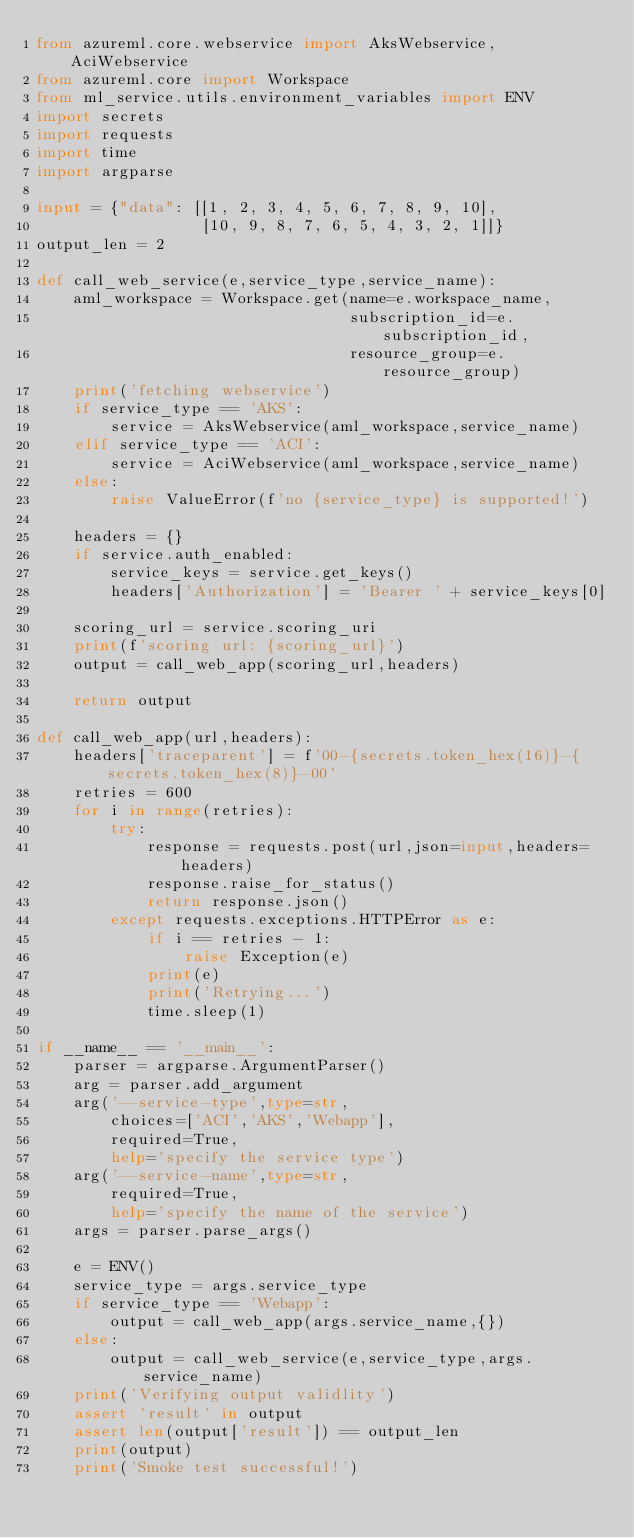<code> <loc_0><loc_0><loc_500><loc_500><_Python_>from azureml.core.webservice import AksWebservice,AciWebservice
from azureml.core import Workspace
from ml_service.utils.environment_variables import ENV
import secrets
import requests
import time
import argparse

input = {"data": [[1, 2, 3, 4, 5, 6, 7, 8, 9, 10],
                  [10, 9, 8, 7, 6, 5, 4, 3, 2, 1]]}
output_len = 2

def call_web_service(e,service_type,service_name):
    aml_workspace = Workspace.get(name=e.workspace_name,
                                  subscription_id=e.subscription_id,
                                  resource_group=e.resource_group)
    print('fetching webservice')
    if service_type == 'AKS':
        service = AksWebservice(aml_workspace,service_name)
    elif service_type == 'ACI':
        service = AciWebservice(aml_workspace,service_name)
    else:
        raise ValueError(f'no {service_type} is supported!')
    
    headers = {}
    if service.auth_enabled:
        service_keys = service.get_keys()
        headers['Authorization'] = 'Bearer ' + service_keys[0]
    
    scoring_url = service.scoring_uri
    print(f'scoring url: {scoring_url}')
    output = call_web_app(scoring_url,headers)
    
    return output

def call_web_app(url,headers):
    headers['traceparent'] = f'00-{secrets.token_hex(16)}-{secrets.token_hex(8)}-00'
    retries = 600
    for i in range(retries):
        try:
            response = requests.post(url,json=input,headers=headers)
            response.raise_for_status()
            return response.json()
        except requests.exceptions.HTTPError as e:
            if i == retries - 1:
                raise Exception(e)
            print(e)
            print('Retrying...')
            time.sleep(1)

if __name__ == '__main__':
    parser = argparse.ArgumentParser()
    arg = parser.add_argument
    arg('--service-type',type=str,
        choices=['ACI','AKS','Webapp'],
        required=True,
        help='specify the service type')
    arg('--service-name',type=str,
        required=True,
        help='specify the name of the service')
    args = parser.parse_args()
    
    e = ENV()
    service_type = args.service_type
    if service_type == 'Webapp':
        output = call_web_app(args.service_name,{})
    else:
        output = call_web_service(e,service_type,args.service_name)
    print('Verifying output validlity')
    assert 'result' in output
    assert len(output['result']) == output_len
    print(output)
    print('Smoke test successful!')
    
    

</code> 